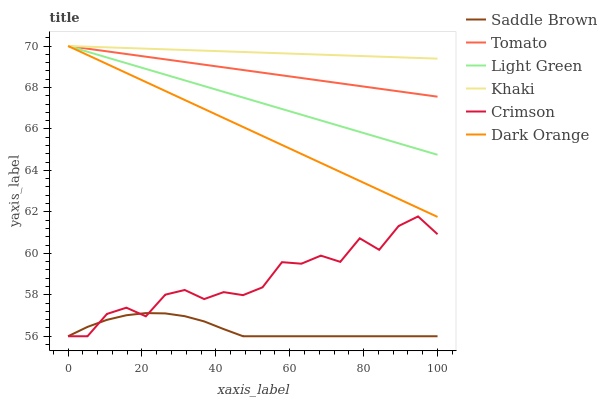Does Saddle Brown have the minimum area under the curve?
Answer yes or no. Yes. Does Khaki have the maximum area under the curve?
Answer yes or no. Yes. Does Dark Orange have the minimum area under the curve?
Answer yes or no. No. Does Dark Orange have the maximum area under the curve?
Answer yes or no. No. Is Tomato the smoothest?
Answer yes or no. Yes. Is Crimson the roughest?
Answer yes or no. Yes. Is Dark Orange the smoothest?
Answer yes or no. No. Is Dark Orange the roughest?
Answer yes or no. No. Does Crimson have the lowest value?
Answer yes or no. Yes. Does Dark Orange have the lowest value?
Answer yes or no. No. Does Light Green have the highest value?
Answer yes or no. Yes. Does Crimson have the highest value?
Answer yes or no. No. Is Crimson less than Tomato?
Answer yes or no. Yes. Is Dark Orange greater than Saddle Brown?
Answer yes or no. Yes. Does Crimson intersect Saddle Brown?
Answer yes or no. Yes. Is Crimson less than Saddle Brown?
Answer yes or no. No. Is Crimson greater than Saddle Brown?
Answer yes or no. No. Does Crimson intersect Tomato?
Answer yes or no. No. 